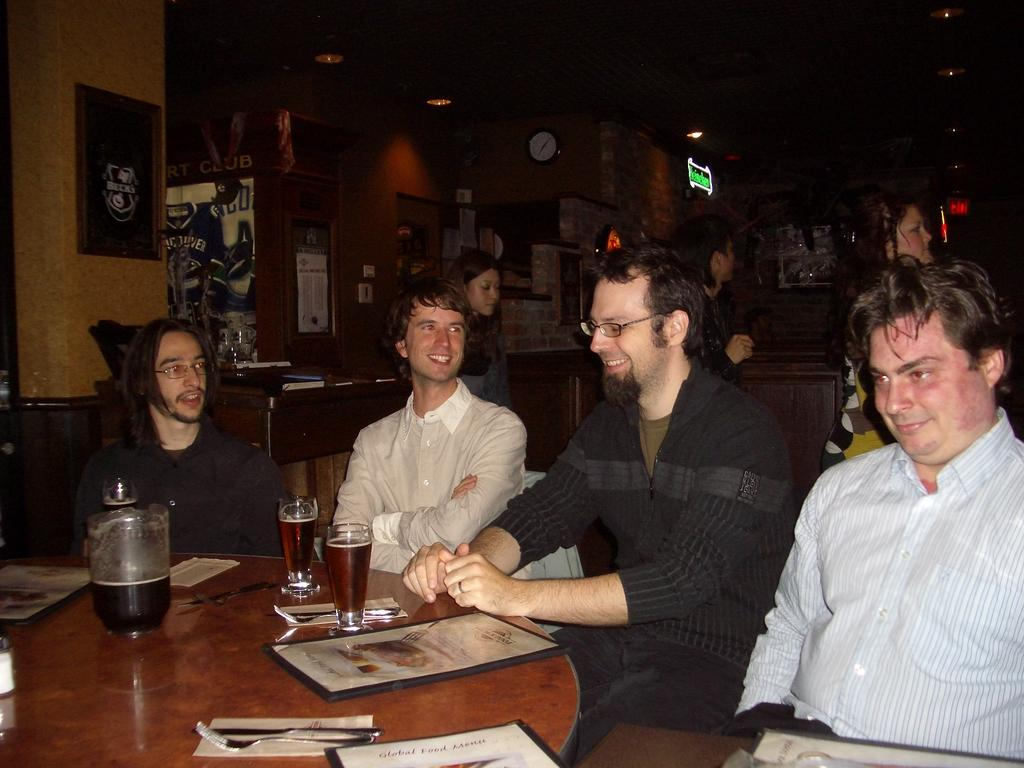What type of structure can be seen in the image? There is a wall in the image. What is hanging on the wall in the image? There is a photo frame in the image. What time-telling device is present in the image? There is a clock in the image. What are the people in the image doing? There are people sitting on chairs in the image. What piece of furniture is present in the image? There is a table in the image. What utensils can be seen on the table in the image? On the table, there is a fork and a spoon. What other items can be seen on the table in the image? On the table, there is a frame, a glass, and a paper. Can you see any twigs on the table in the image? There are no twigs present on the table in the image. How does the destruction of the wall affect the people sitting on chairs in the image? The image does not depict any destruction or damage to the wall, so it does not affect the people sitting on chairs. 